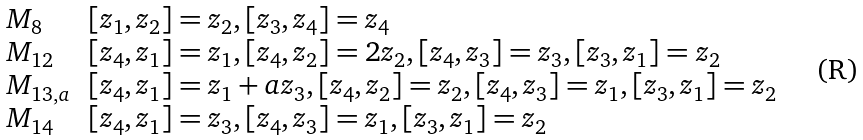Convert formula to latex. <formula><loc_0><loc_0><loc_500><loc_500>\begin{array} { l l l l } M _ { 8 } & [ z _ { 1 } , z _ { 2 } ] = z _ { 2 } , [ z _ { 3 } , z _ { 4 } ] = z _ { 4 } \\ M _ { 1 2 } & [ z _ { 4 } , z _ { 1 } ] = z _ { 1 } , [ z _ { 4 } , z _ { 2 } ] = 2 z _ { 2 } , [ z _ { 4 } , z _ { 3 } ] = z _ { 3 } , [ z _ { 3 } , z _ { 1 } ] = z _ { 2 } \\ M _ { 1 3 , a } & [ z _ { 4 } , z _ { 1 } ] = z _ { 1 } + a z _ { 3 } , [ z _ { 4 } , z _ { 2 } ] = z _ { 2 } , [ z _ { 4 } , z _ { 3 } ] = z _ { 1 } , [ z _ { 3 } , z _ { 1 } ] = z _ { 2 } \\ M _ { 1 4 } & [ z _ { 4 } , z _ { 1 } ] = z _ { 3 } , [ z _ { 4 } , z _ { 3 } ] = z _ { 1 } , [ z _ { 3 } , z _ { 1 } ] = z _ { 2 } \\ \end{array}</formula> 